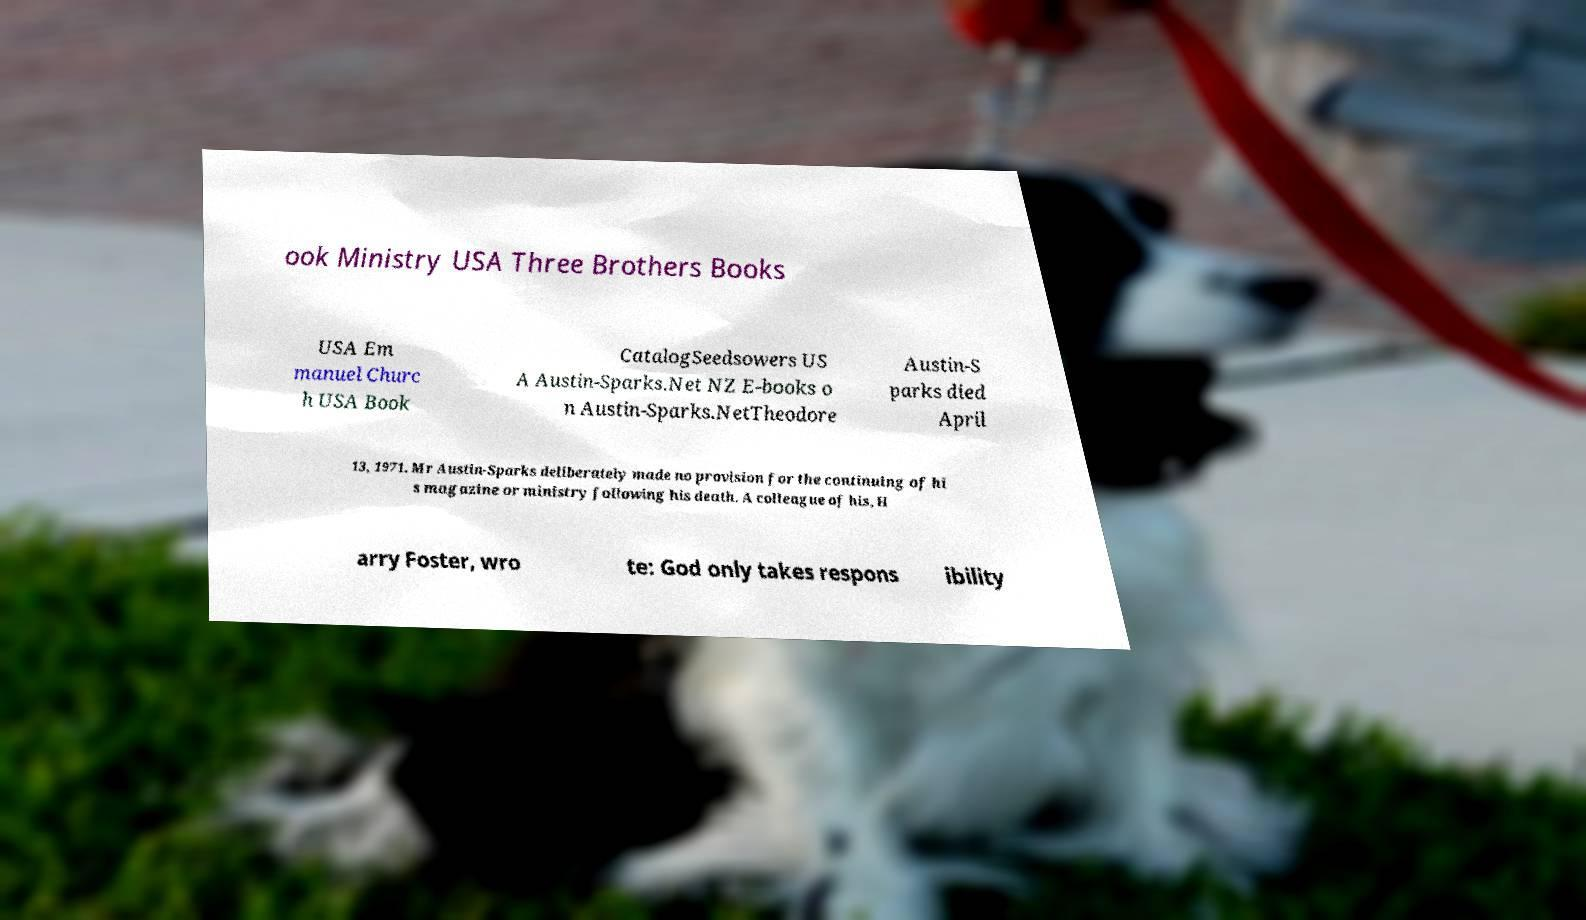For documentation purposes, I need the text within this image transcribed. Could you provide that? ook Ministry USA Three Brothers Books USA Em manuel Churc h USA Book CatalogSeedsowers US A Austin-Sparks.Net NZ E-books o n Austin-Sparks.NetTheodore Austin-S parks died April 13, 1971. Mr Austin-Sparks deliberately made no provision for the continuing of hi s magazine or ministry following his death. A colleague of his, H arry Foster, wro te: God only takes respons ibility 